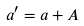Convert formula to latex. <formula><loc_0><loc_0><loc_500><loc_500>a ^ { \prime } = a + A</formula> 